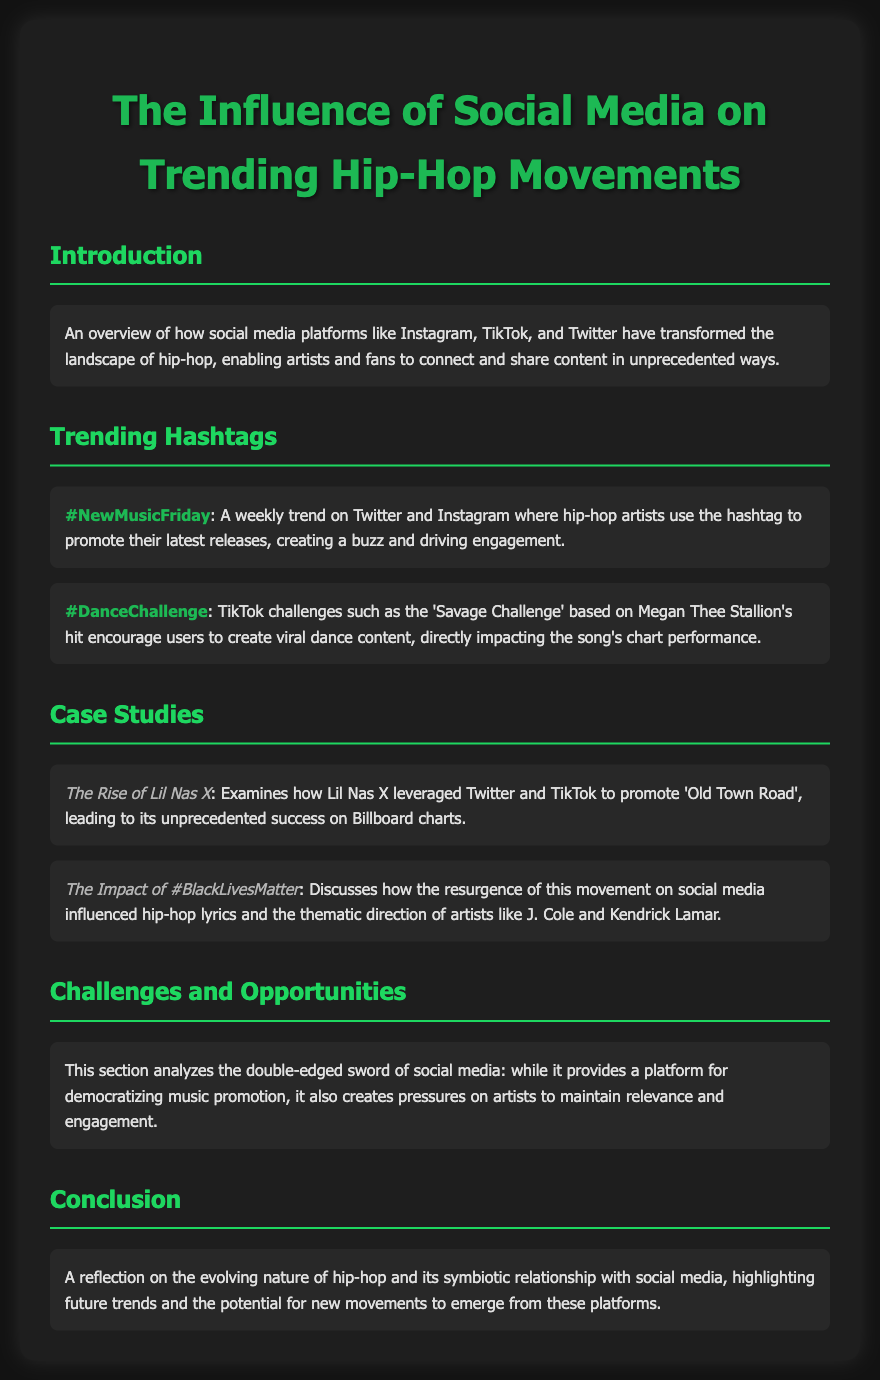what is the title of the report? The title is presented in the document header, reflecting the content focus on social media's influence on hip-hop.
Answer: The Influence of Social Media on Trending Hip-Hop Movements which hashtag is associated with promoting new music? The document specifically mentions a hashtag that artists use weekly to generate buzz around their music.
Answer: #NewMusicFriday who is the artist discussed in the case study about 'Old Town Road'? The document includes a section that highlights how this artist used social media for promotion.
Answer: Lil Nas X what is the impact of the hashtag #BlackLivesMatter on hip-hop? The document mentions how this social movement influenced the lyrical themes among specific artists.
Answer: Influenced hip-hop lyrics and themes which social media platforms are highlighted in the introduction? The report mentions specific platforms that transformed the hip-hop landscape in the introduction section.
Answer: Instagram, TikTok, Twitter what kind of challenges do artists face with social media? The document addresses pressures on artists created by the platforms where they promote their music.
Answer: Maintaining relevance and engagement how does the report conclude about the relationship between hip-hop and social media? The conclusion summarizes the evolving connection and future implications of this relationship.
Answer: Symbiotic relationship with social media what is a notable TikTok challenge mentioned in the report? The document specifies a viral dance challenge directly related to a hip-hop song.
Answer: Savage Challenge 